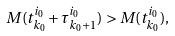Convert formula to latex. <formula><loc_0><loc_0><loc_500><loc_500>M ( t ^ { i _ { 0 } } _ { k _ { 0 } } + \tau ^ { i _ { 0 } } _ { k _ { 0 } + 1 } ) > M ( t ^ { i _ { 0 } } _ { k _ { 0 } } ) ,</formula> 